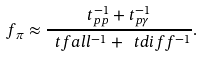<formula> <loc_0><loc_0><loc_500><loc_500>f _ { \pi } \approx \frac { t _ { p p } ^ { - 1 } + t _ { p \gamma } ^ { - 1 } } { \ t f a l l ^ { - 1 } + \ t d i f f ^ { - 1 } } .</formula> 